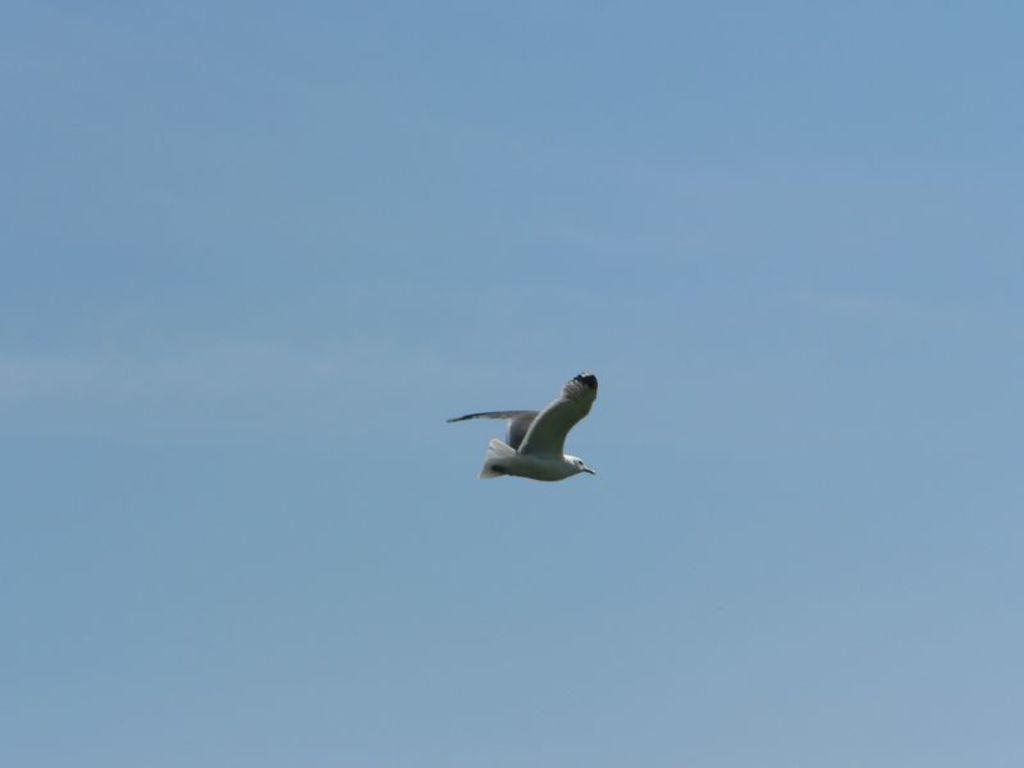Could you give a brief overview of what you see in this image? In the center of the image we can see one bird flying, which is in white color. In the background we can see the sky. 